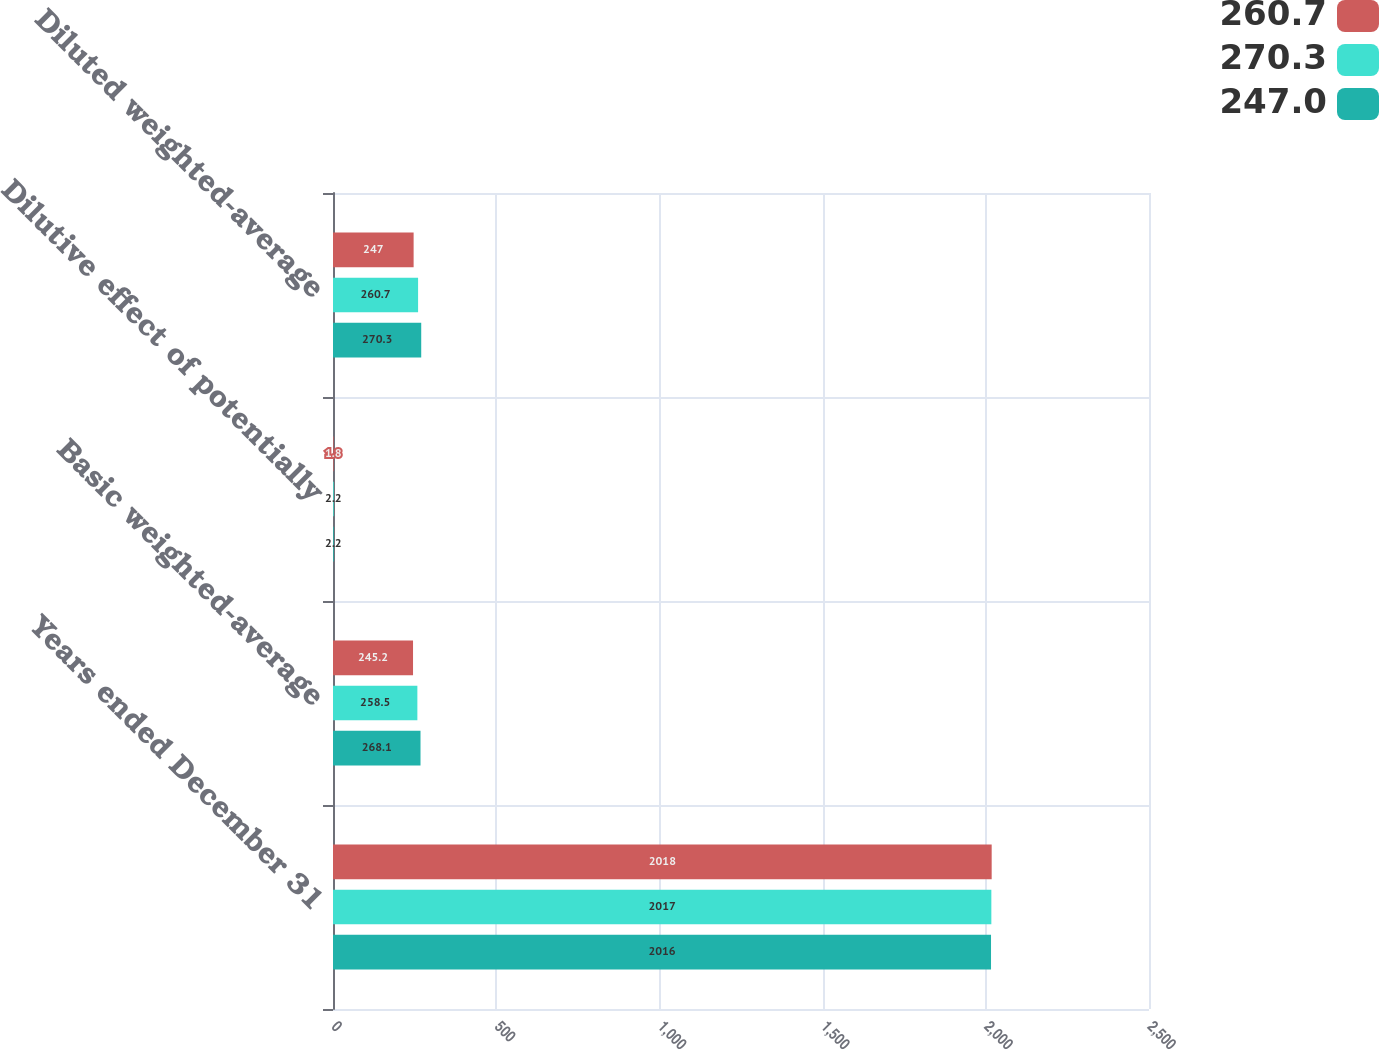<chart> <loc_0><loc_0><loc_500><loc_500><stacked_bar_chart><ecel><fcel>Years ended December 31<fcel>Basic weighted-average<fcel>Dilutive effect of potentially<fcel>Diluted weighted-average<nl><fcel>260.7<fcel>2018<fcel>245.2<fcel>1.8<fcel>247<nl><fcel>270.3<fcel>2017<fcel>258.5<fcel>2.2<fcel>260.7<nl><fcel>247<fcel>2016<fcel>268.1<fcel>2.2<fcel>270.3<nl></chart> 